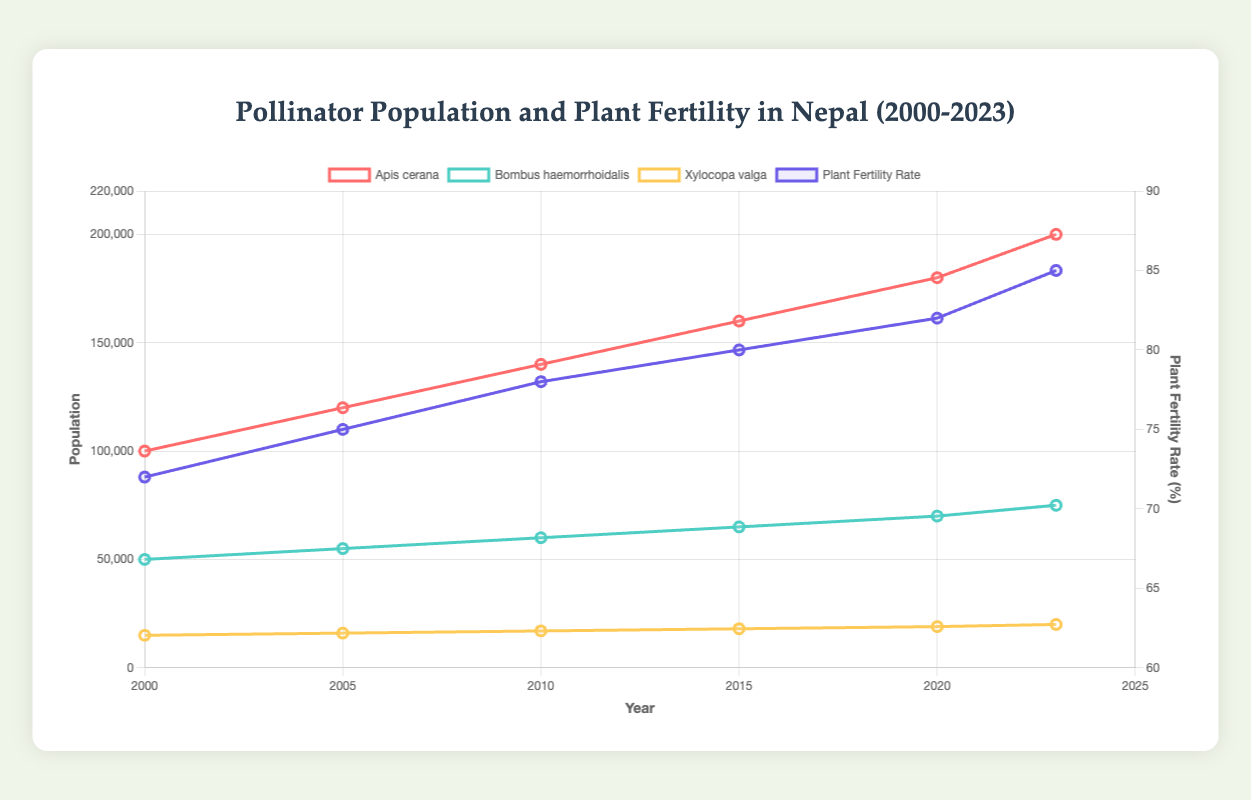What is the population of Apis cerana in 2020? Look at the 2020 data point for Apis cerana and read the population value.
Answer: 180000 Which pollinator species had the highest population in 2023? Compare the population data for Apis cerana, Bombus haemorrhoidalis, and Xylocopa valga in 2023. The highest population is observed.
Answer: Apis cerana By how much did the plant fertility rate increase from 2000 to 2023? Find the plant fertility rate in both 2000 and 2023 and calculate the difference: 85 (2023) - 72 (2000) = 13.
Answer: 13 What is the average annual growth rate of Bombus haemorrhoidalis' population from 2005 to 2015? Calculate the total population increase from 2005 to 2015 (65000-55000=10000) and divide by the number of years (10): 10000/10.
Answer: 1000 How does the fertility rate trend correlate with Apis cerana population growth? As the population of Apis cerana increases from 2000 to 2023, the fertility rate also shows an increasing trend, indicating a positive correlation.
Answer: Positive correlation What is the relative growth in population for Xylocopa valga from 2000 to 2023? Calculate the initial and final population values (20000-15000) and find the ratio of the absolute increase to the initial population: (20000-15000)/15000.
Answer: 0.33 (or 33%) Which pollinator species had the least population change from 2010 to 2020? Compare the population differences for each species between 2010 and 2020. Xylocopa valga has the smallest change (19000-17000=2000).
Answer: Xylocopa valga What was the plant fertility rate at the year when Bombus haemorrhoidalis had a population of 60000? Find the year when Bombus haemorrhoidalis' population was 60000 (2010), then check the plant fertility rate for that year (72).
Answer: 72 How did the population of Bombus haemorrhoidalis compare to Xylocopa valga in 2015? Compare the 2015 population data for Bombus haemorrhoidalis (65000) and Xylocopa valga (18000). Bombus haemorrhoidalis had the higher population.
Answer: Bombus haemorrhoidalis What is the trend observed for plant fertility rate from 2000 to 2023? Observe the plant fertility rate values from each year: 72 (2000), 75 (2005), 78 (2010), 80 (2015), 82 (2020), 85 (2023). Notice an upward trend over the years.
Answer: Increasing trend 